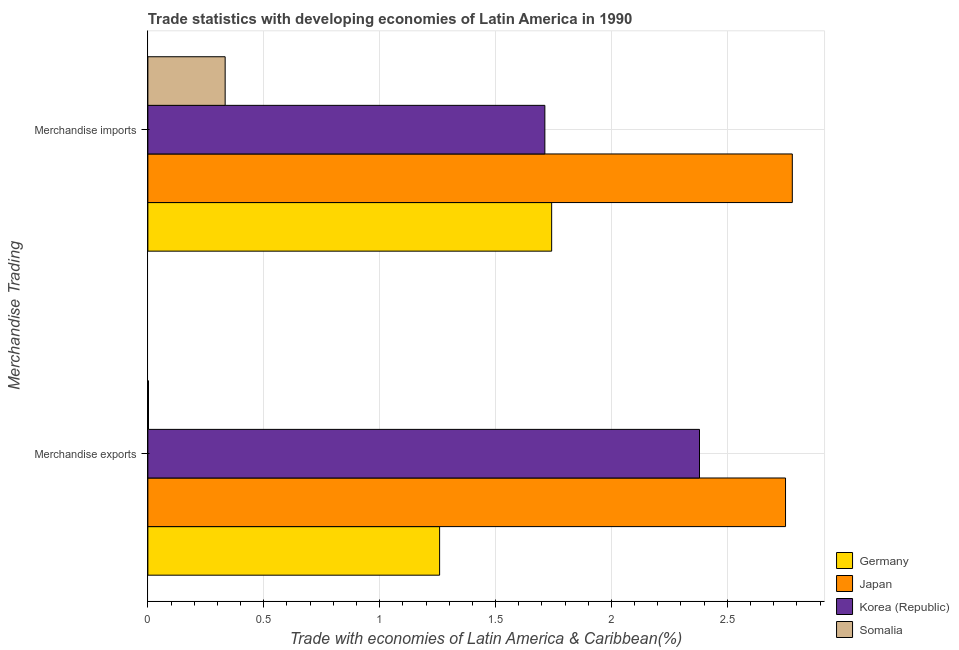How many different coloured bars are there?
Make the answer very short. 4. How many groups of bars are there?
Make the answer very short. 2. Are the number of bars per tick equal to the number of legend labels?
Your answer should be very brief. Yes. Are the number of bars on each tick of the Y-axis equal?
Ensure brevity in your answer.  Yes. What is the label of the 1st group of bars from the top?
Your answer should be very brief. Merchandise imports. What is the merchandise imports in Korea (Republic)?
Give a very brief answer. 1.71. Across all countries, what is the maximum merchandise imports?
Ensure brevity in your answer.  2.78. Across all countries, what is the minimum merchandise exports?
Keep it short and to the point. 0. In which country was the merchandise imports minimum?
Your answer should be very brief. Somalia. What is the total merchandise imports in the graph?
Provide a succinct answer. 6.57. What is the difference between the merchandise imports in Korea (Republic) and that in Germany?
Give a very brief answer. -0.03. What is the difference between the merchandise imports in Germany and the merchandise exports in Somalia?
Provide a succinct answer. 1.74. What is the average merchandise exports per country?
Offer a terse response. 1.6. What is the difference between the merchandise imports and merchandise exports in Japan?
Offer a terse response. 0.03. In how many countries, is the merchandise imports greater than 1.7 %?
Your answer should be compact. 3. What is the ratio of the merchandise exports in Korea (Republic) to that in Japan?
Your response must be concise. 0.87. Is the merchandise exports in Korea (Republic) less than that in Somalia?
Make the answer very short. No. In how many countries, is the merchandise imports greater than the average merchandise imports taken over all countries?
Provide a short and direct response. 3. How many bars are there?
Provide a short and direct response. 8. Are all the bars in the graph horizontal?
Keep it short and to the point. Yes. How many countries are there in the graph?
Your answer should be compact. 4. What is the difference between two consecutive major ticks on the X-axis?
Provide a succinct answer. 0.5. Does the graph contain grids?
Offer a terse response. Yes. Where does the legend appear in the graph?
Keep it short and to the point. Bottom right. How many legend labels are there?
Your answer should be very brief. 4. How are the legend labels stacked?
Give a very brief answer. Vertical. What is the title of the graph?
Offer a very short reply. Trade statistics with developing economies of Latin America in 1990. Does "Congo (Republic)" appear as one of the legend labels in the graph?
Your response must be concise. No. What is the label or title of the X-axis?
Ensure brevity in your answer.  Trade with economies of Latin America & Caribbean(%). What is the label or title of the Y-axis?
Provide a succinct answer. Merchandise Trading. What is the Trade with economies of Latin America & Caribbean(%) in Germany in Merchandise exports?
Offer a very short reply. 1.26. What is the Trade with economies of Latin America & Caribbean(%) in Japan in Merchandise exports?
Your answer should be very brief. 2.75. What is the Trade with economies of Latin America & Caribbean(%) of Korea (Republic) in Merchandise exports?
Give a very brief answer. 2.38. What is the Trade with economies of Latin America & Caribbean(%) in Somalia in Merchandise exports?
Your response must be concise. 0. What is the Trade with economies of Latin America & Caribbean(%) of Germany in Merchandise imports?
Your answer should be very brief. 1.74. What is the Trade with economies of Latin America & Caribbean(%) of Japan in Merchandise imports?
Make the answer very short. 2.78. What is the Trade with economies of Latin America & Caribbean(%) in Korea (Republic) in Merchandise imports?
Provide a succinct answer. 1.71. What is the Trade with economies of Latin America & Caribbean(%) in Somalia in Merchandise imports?
Provide a short and direct response. 0.33. Across all Merchandise Trading, what is the maximum Trade with economies of Latin America & Caribbean(%) of Germany?
Your answer should be very brief. 1.74. Across all Merchandise Trading, what is the maximum Trade with economies of Latin America & Caribbean(%) in Japan?
Make the answer very short. 2.78. Across all Merchandise Trading, what is the maximum Trade with economies of Latin America & Caribbean(%) in Korea (Republic)?
Ensure brevity in your answer.  2.38. Across all Merchandise Trading, what is the maximum Trade with economies of Latin America & Caribbean(%) of Somalia?
Provide a short and direct response. 0.33. Across all Merchandise Trading, what is the minimum Trade with economies of Latin America & Caribbean(%) in Germany?
Your response must be concise. 1.26. Across all Merchandise Trading, what is the minimum Trade with economies of Latin America & Caribbean(%) of Japan?
Provide a succinct answer. 2.75. Across all Merchandise Trading, what is the minimum Trade with economies of Latin America & Caribbean(%) in Korea (Republic)?
Your response must be concise. 1.71. Across all Merchandise Trading, what is the minimum Trade with economies of Latin America & Caribbean(%) in Somalia?
Ensure brevity in your answer.  0. What is the total Trade with economies of Latin America & Caribbean(%) in Germany in the graph?
Ensure brevity in your answer.  3. What is the total Trade with economies of Latin America & Caribbean(%) in Japan in the graph?
Provide a short and direct response. 5.53. What is the total Trade with economies of Latin America & Caribbean(%) of Korea (Republic) in the graph?
Give a very brief answer. 4.09. What is the total Trade with economies of Latin America & Caribbean(%) of Somalia in the graph?
Keep it short and to the point. 0.34. What is the difference between the Trade with economies of Latin America & Caribbean(%) of Germany in Merchandise exports and that in Merchandise imports?
Ensure brevity in your answer.  -0.48. What is the difference between the Trade with economies of Latin America & Caribbean(%) in Japan in Merchandise exports and that in Merchandise imports?
Your answer should be compact. -0.03. What is the difference between the Trade with economies of Latin America & Caribbean(%) of Korea (Republic) in Merchandise exports and that in Merchandise imports?
Make the answer very short. 0.67. What is the difference between the Trade with economies of Latin America & Caribbean(%) in Somalia in Merchandise exports and that in Merchandise imports?
Provide a succinct answer. -0.33. What is the difference between the Trade with economies of Latin America & Caribbean(%) of Germany in Merchandise exports and the Trade with economies of Latin America & Caribbean(%) of Japan in Merchandise imports?
Provide a succinct answer. -1.52. What is the difference between the Trade with economies of Latin America & Caribbean(%) in Germany in Merchandise exports and the Trade with economies of Latin America & Caribbean(%) in Korea (Republic) in Merchandise imports?
Your answer should be very brief. -0.45. What is the difference between the Trade with economies of Latin America & Caribbean(%) of Germany in Merchandise exports and the Trade with economies of Latin America & Caribbean(%) of Somalia in Merchandise imports?
Your answer should be very brief. 0.93. What is the difference between the Trade with economies of Latin America & Caribbean(%) in Japan in Merchandise exports and the Trade with economies of Latin America & Caribbean(%) in Korea (Republic) in Merchandise imports?
Your answer should be very brief. 1.04. What is the difference between the Trade with economies of Latin America & Caribbean(%) of Japan in Merchandise exports and the Trade with economies of Latin America & Caribbean(%) of Somalia in Merchandise imports?
Offer a terse response. 2.42. What is the difference between the Trade with economies of Latin America & Caribbean(%) in Korea (Republic) in Merchandise exports and the Trade with economies of Latin America & Caribbean(%) in Somalia in Merchandise imports?
Your response must be concise. 2.05. What is the average Trade with economies of Latin America & Caribbean(%) in Germany per Merchandise Trading?
Offer a terse response. 1.5. What is the average Trade with economies of Latin America & Caribbean(%) in Japan per Merchandise Trading?
Provide a short and direct response. 2.77. What is the average Trade with economies of Latin America & Caribbean(%) in Korea (Republic) per Merchandise Trading?
Give a very brief answer. 2.05. What is the average Trade with economies of Latin America & Caribbean(%) of Somalia per Merchandise Trading?
Provide a succinct answer. 0.17. What is the difference between the Trade with economies of Latin America & Caribbean(%) in Germany and Trade with economies of Latin America & Caribbean(%) in Japan in Merchandise exports?
Offer a very short reply. -1.49. What is the difference between the Trade with economies of Latin America & Caribbean(%) of Germany and Trade with economies of Latin America & Caribbean(%) of Korea (Republic) in Merchandise exports?
Offer a terse response. -1.12. What is the difference between the Trade with economies of Latin America & Caribbean(%) of Germany and Trade with economies of Latin America & Caribbean(%) of Somalia in Merchandise exports?
Your response must be concise. 1.26. What is the difference between the Trade with economies of Latin America & Caribbean(%) in Japan and Trade with economies of Latin America & Caribbean(%) in Korea (Republic) in Merchandise exports?
Keep it short and to the point. 0.37. What is the difference between the Trade with economies of Latin America & Caribbean(%) of Japan and Trade with economies of Latin America & Caribbean(%) of Somalia in Merchandise exports?
Provide a succinct answer. 2.75. What is the difference between the Trade with economies of Latin America & Caribbean(%) in Korea (Republic) and Trade with economies of Latin America & Caribbean(%) in Somalia in Merchandise exports?
Your response must be concise. 2.38. What is the difference between the Trade with economies of Latin America & Caribbean(%) in Germany and Trade with economies of Latin America & Caribbean(%) in Japan in Merchandise imports?
Keep it short and to the point. -1.04. What is the difference between the Trade with economies of Latin America & Caribbean(%) in Germany and Trade with economies of Latin America & Caribbean(%) in Korea (Republic) in Merchandise imports?
Make the answer very short. 0.03. What is the difference between the Trade with economies of Latin America & Caribbean(%) of Germany and Trade with economies of Latin America & Caribbean(%) of Somalia in Merchandise imports?
Give a very brief answer. 1.41. What is the difference between the Trade with economies of Latin America & Caribbean(%) in Japan and Trade with economies of Latin America & Caribbean(%) in Korea (Republic) in Merchandise imports?
Keep it short and to the point. 1.07. What is the difference between the Trade with economies of Latin America & Caribbean(%) in Japan and Trade with economies of Latin America & Caribbean(%) in Somalia in Merchandise imports?
Offer a terse response. 2.45. What is the difference between the Trade with economies of Latin America & Caribbean(%) of Korea (Republic) and Trade with economies of Latin America & Caribbean(%) of Somalia in Merchandise imports?
Ensure brevity in your answer.  1.38. What is the ratio of the Trade with economies of Latin America & Caribbean(%) in Germany in Merchandise exports to that in Merchandise imports?
Your answer should be compact. 0.72. What is the ratio of the Trade with economies of Latin America & Caribbean(%) in Japan in Merchandise exports to that in Merchandise imports?
Your answer should be very brief. 0.99. What is the ratio of the Trade with economies of Latin America & Caribbean(%) of Korea (Republic) in Merchandise exports to that in Merchandise imports?
Your answer should be very brief. 1.39. What is the ratio of the Trade with economies of Latin America & Caribbean(%) in Somalia in Merchandise exports to that in Merchandise imports?
Your answer should be compact. 0.01. What is the difference between the highest and the second highest Trade with economies of Latin America & Caribbean(%) of Germany?
Give a very brief answer. 0.48. What is the difference between the highest and the second highest Trade with economies of Latin America & Caribbean(%) of Japan?
Give a very brief answer. 0.03. What is the difference between the highest and the second highest Trade with economies of Latin America & Caribbean(%) in Korea (Republic)?
Give a very brief answer. 0.67. What is the difference between the highest and the second highest Trade with economies of Latin America & Caribbean(%) in Somalia?
Offer a terse response. 0.33. What is the difference between the highest and the lowest Trade with economies of Latin America & Caribbean(%) in Germany?
Make the answer very short. 0.48. What is the difference between the highest and the lowest Trade with economies of Latin America & Caribbean(%) of Japan?
Offer a terse response. 0.03. What is the difference between the highest and the lowest Trade with economies of Latin America & Caribbean(%) in Korea (Republic)?
Offer a terse response. 0.67. What is the difference between the highest and the lowest Trade with economies of Latin America & Caribbean(%) of Somalia?
Provide a short and direct response. 0.33. 